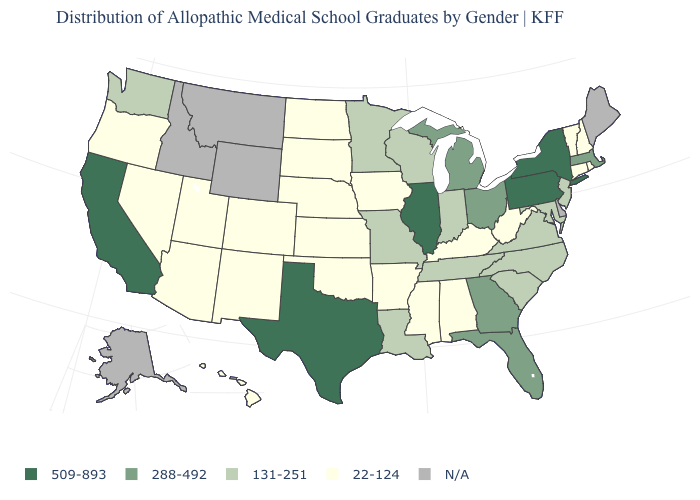What is the value of Alaska?
Write a very short answer. N/A. What is the value of Ohio?
Write a very short answer. 288-492. What is the value of New York?
Answer briefly. 509-893. What is the lowest value in the USA?
Be succinct. 22-124. Name the states that have a value in the range 131-251?
Keep it brief. Indiana, Louisiana, Maryland, Minnesota, Missouri, New Jersey, North Carolina, South Carolina, Tennessee, Virginia, Washington, Wisconsin. Does Texas have the highest value in the South?
Quick response, please. Yes. Does Arizona have the lowest value in the West?
Give a very brief answer. Yes. Which states have the lowest value in the USA?
Give a very brief answer. Alabama, Arizona, Arkansas, Colorado, Connecticut, Hawaii, Iowa, Kansas, Kentucky, Mississippi, Nebraska, Nevada, New Hampshire, New Mexico, North Dakota, Oklahoma, Oregon, Rhode Island, South Dakota, Utah, Vermont, West Virginia. Among the states that border Maryland , does West Virginia have the highest value?
Concise answer only. No. What is the lowest value in the USA?
Quick response, please. 22-124. Among the states that border Nebraska , does South Dakota have the highest value?
Answer briefly. No. Does Alabama have the lowest value in the South?
Concise answer only. Yes. Which states have the lowest value in the USA?
Concise answer only. Alabama, Arizona, Arkansas, Colorado, Connecticut, Hawaii, Iowa, Kansas, Kentucky, Mississippi, Nebraska, Nevada, New Hampshire, New Mexico, North Dakota, Oklahoma, Oregon, Rhode Island, South Dakota, Utah, Vermont, West Virginia. Name the states that have a value in the range N/A?
Be succinct. Alaska, Delaware, Idaho, Maine, Montana, Wyoming. Among the states that border Arkansas , does Oklahoma have the lowest value?
Quick response, please. Yes. 